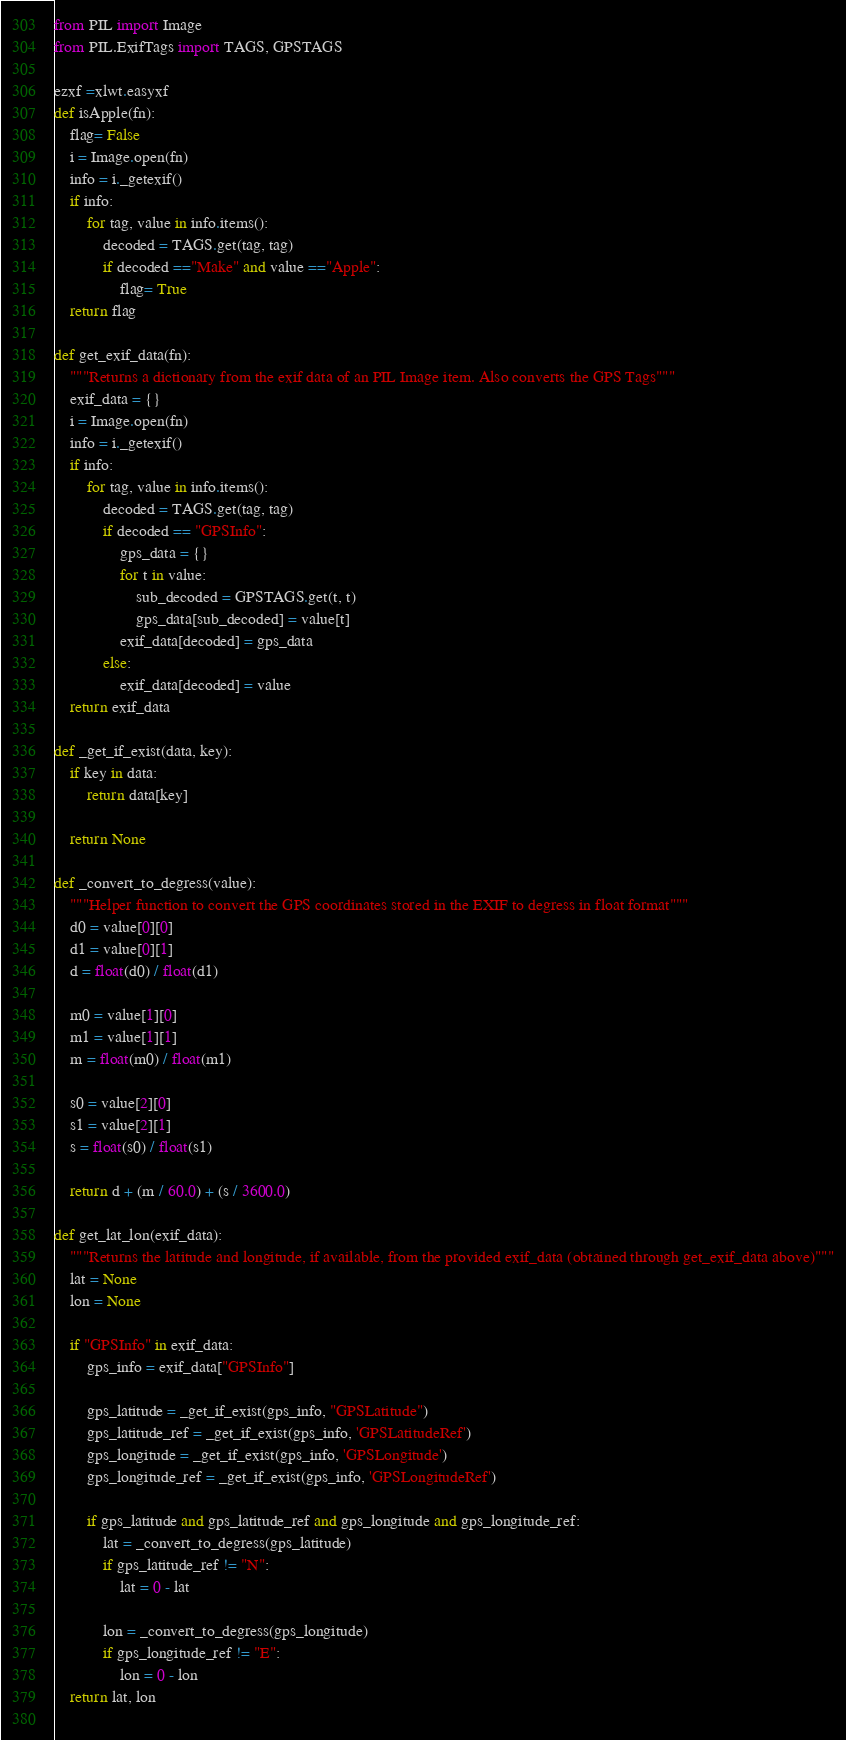Convert code to text. <code><loc_0><loc_0><loc_500><loc_500><_Python_>from PIL import Image
from PIL.ExifTags import TAGS, GPSTAGS

ezxf =xlwt.easyxf
def isApple(fn):
	flag= False
	i = Image.open(fn)
	info = i._getexif()
	if info:
		for tag, value in info.items():
			decoded = TAGS.get(tag, tag)
			if decoded =="Make" and value =="Apple":
				flag= True
	return flag

def get_exif_data(fn):
	"""Returns a dictionary from the exif data of an PIL Image item. Also converts the GPS Tags"""
	exif_data = {}
	i = Image.open(fn)
	info = i._getexif()
	if info:
		for tag, value in info.items():
			decoded = TAGS.get(tag, tag)
			if decoded == "GPSInfo":
				gps_data = {}
				for t in value:
					sub_decoded = GPSTAGS.get(t, t)
					gps_data[sub_decoded] = value[t]
				exif_data[decoded] = gps_data
			else:
				exif_data[decoded] = value
	return exif_data
 
def _get_if_exist(data, key):
    if key in data:
        return data[key]
		
    return None
	
def _convert_to_degress(value):
    """Helper function to convert the GPS coordinates stored in the EXIF to degress in float format"""
    d0 = value[0][0]
    d1 = value[0][1]
    d = float(d0) / float(d1)
 
    m0 = value[1][0]
    m1 = value[1][1]
    m = float(m0) / float(m1)
 
    s0 = value[2][0]
    s1 = value[2][1]
    s = float(s0) / float(s1)
 
    return d + (m / 60.0) + (s / 3600.0)
 
def get_lat_lon(exif_data):
    """Returns the latitude and longitude, if available, from the provided exif_data (obtained through get_exif_data above)"""
    lat = None
    lon = None

    if "GPSInfo" in exif_data:		
        gps_info = exif_data["GPSInfo"]
 
        gps_latitude = _get_if_exist(gps_info, "GPSLatitude")
        gps_latitude_ref = _get_if_exist(gps_info, 'GPSLatitudeRef')
        gps_longitude = _get_if_exist(gps_info, 'GPSLongitude')
        gps_longitude_ref = _get_if_exist(gps_info, 'GPSLongitudeRef')
 
        if gps_latitude and gps_latitude_ref and gps_longitude and gps_longitude_ref:
            lat = _convert_to_degress(gps_latitude)
            if gps_latitude_ref != "N":                     
                lat = 0 - lat
 
            lon = _convert_to_degress(gps_longitude)
            if gps_longitude_ref != "E":
                lon = 0 - lon
    return lat, lon
 </code> 